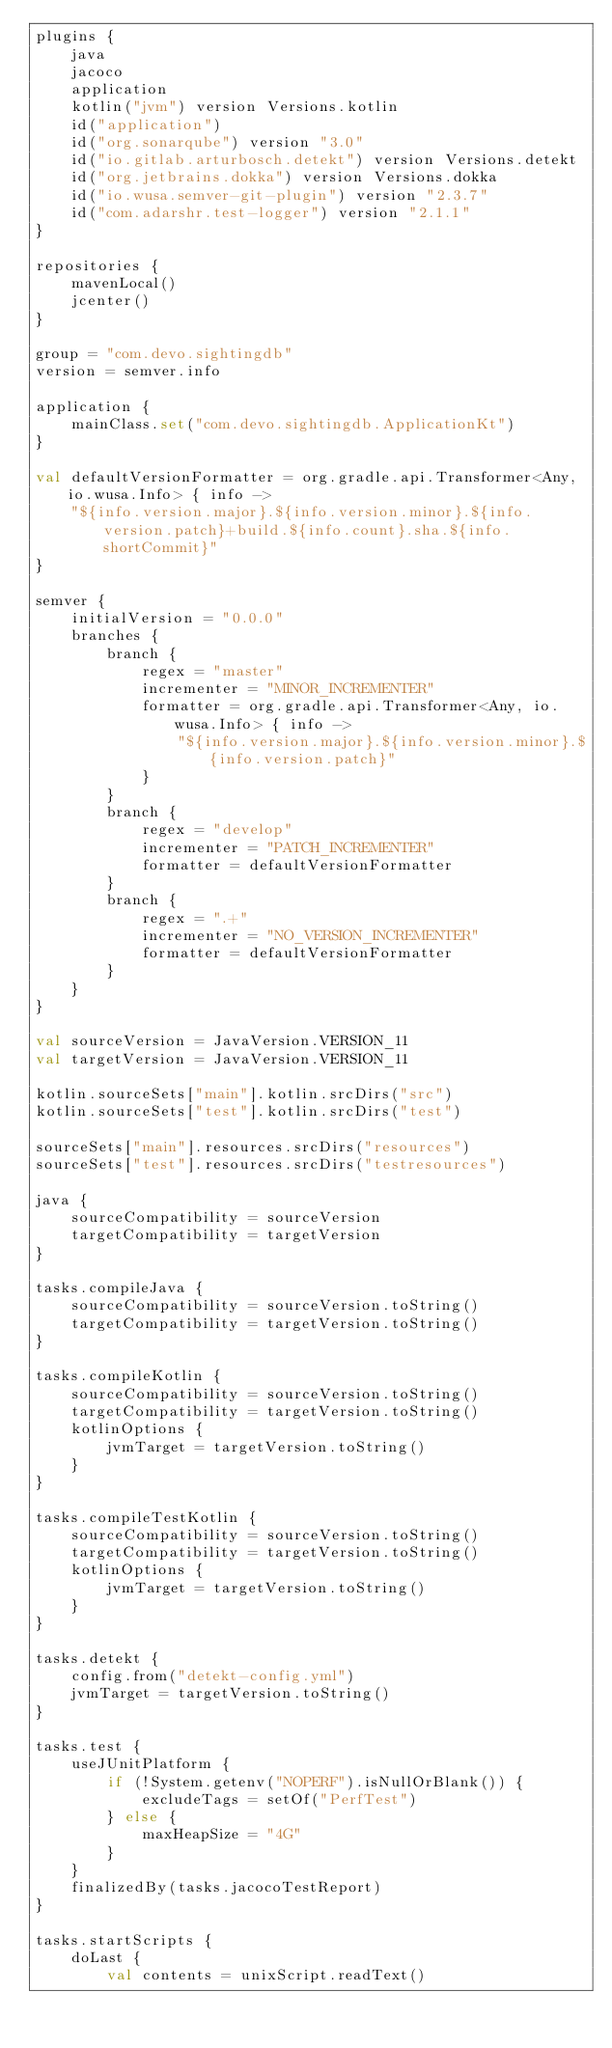<code> <loc_0><loc_0><loc_500><loc_500><_Kotlin_>plugins {
    java
    jacoco
    application
    kotlin("jvm") version Versions.kotlin
    id("application")
    id("org.sonarqube") version "3.0"
    id("io.gitlab.arturbosch.detekt") version Versions.detekt
    id("org.jetbrains.dokka") version Versions.dokka
    id("io.wusa.semver-git-plugin") version "2.3.7"
    id("com.adarshr.test-logger") version "2.1.1"
}

repositories {
    mavenLocal()
    jcenter()
}

group = "com.devo.sightingdb"
version = semver.info

application {
    mainClass.set("com.devo.sightingdb.ApplicationKt")
}

val defaultVersionFormatter = org.gradle.api.Transformer<Any, io.wusa.Info> { info ->
    "${info.version.major}.${info.version.minor}.${info.version.patch}+build.${info.count}.sha.${info.shortCommit}"
}

semver {
    initialVersion = "0.0.0"
    branches {
        branch {
            regex = "master"
            incrementer = "MINOR_INCREMENTER"
            formatter = org.gradle.api.Transformer<Any, io.wusa.Info> { info ->
                "${info.version.major}.${info.version.minor}.${info.version.patch}"
            }
        }
        branch {
            regex = "develop"
            incrementer = "PATCH_INCREMENTER"
            formatter = defaultVersionFormatter
        }
        branch {
            regex = ".+"
            incrementer = "NO_VERSION_INCREMENTER"
            formatter = defaultVersionFormatter
        }
    }
}

val sourceVersion = JavaVersion.VERSION_11
val targetVersion = JavaVersion.VERSION_11

kotlin.sourceSets["main"].kotlin.srcDirs("src")
kotlin.sourceSets["test"].kotlin.srcDirs("test")

sourceSets["main"].resources.srcDirs("resources")
sourceSets["test"].resources.srcDirs("testresources")

java {
    sourceCompatibility = sourceVersion
    targetCompatibility = targetVersion
}

tasks.compileJava {
    sourceCompatibility = sourceVersion.toString()
    targetCompatibility = targetVersion.toString()
}

tasks.compileKotlin {
    sourceCompatibility = sourceVersion.toString()
    targetCompatibility = targetVersion.toString()
    kotlinOptions {
        jvmTarget = targetVersion.toString()
    }
}

tasks.compileTestKotlin {
    sourceCompatibility = sourceVersion.toString()
    targetCompatibility = targetVersion.toString()
    kotlinOptions {
        jvmTarget = targetVersion.toString()
    }
}

tasks.detekt {
    config.from("detekt-config.yml")
    jvmTarget = targetVersion.toString()
}

tasks.test {
    useJUnitPlatform {
        if (!System.getenv("NOPERF").isNullOrBlank()) {
            excludeTags = setOf("PerfTest")
        } else {
            maxHeapSize = "4G"
        }
    }
    finalizedBy(tasks.jacocoTestReport)
}

tasks.startScripts {
    doLast {
        val contents = unixScript.readText()</code> 